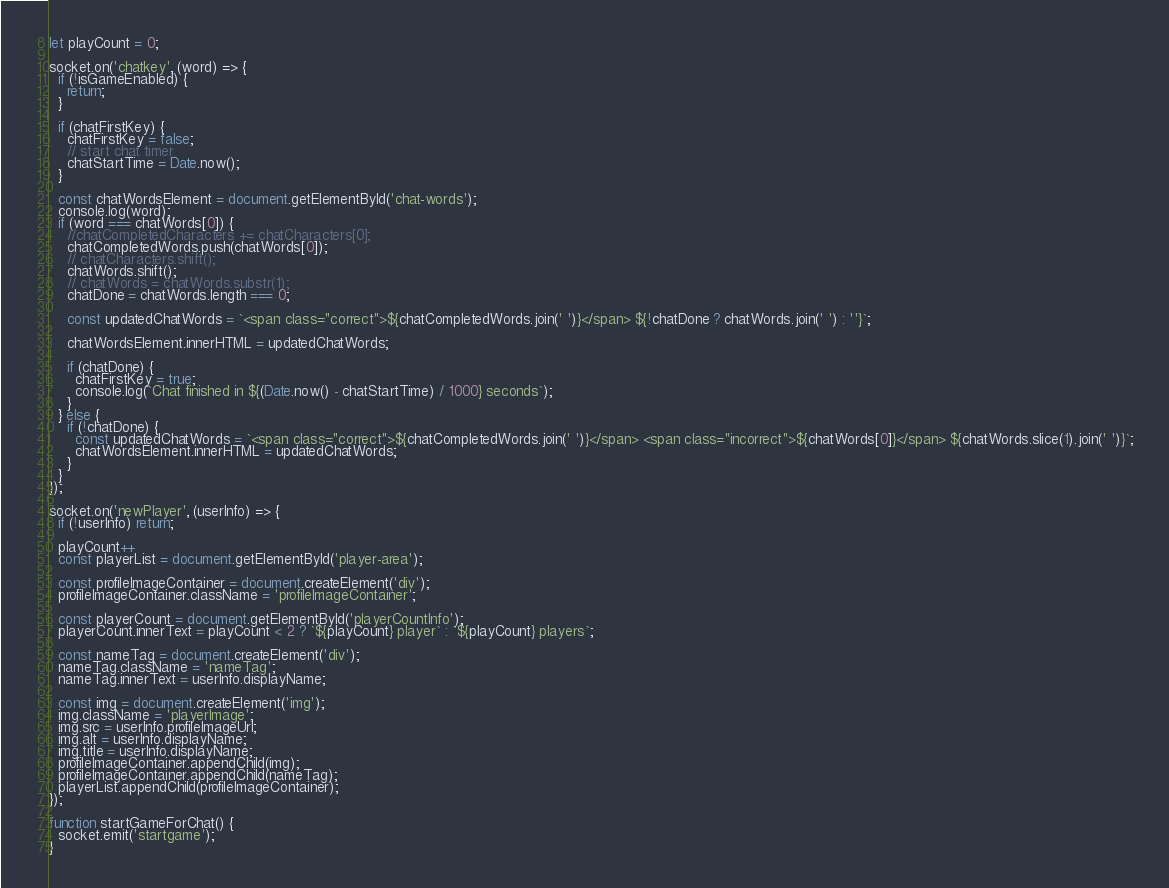<code> <loc_0><loc_0><loc_500><loc_500><_JavaScript_>let playCount = 0;

socket.on('chatkey', (word) => {
  if (!isGameEnabled) {
    return;
  }

  if (chatFirstKey) {
    chatFirstKey = false;
    // start chat timer
    chatStartTime = Date.now();
  }

  const chatWordsElement = document.getElementById('chat-words');
  console.log(word);
  if (word === chatWords[0]) {
    //chatCompletedCharacters += chatCharacters[0];
    chatCompletedWords.push(chatWords[0]);
    // chatCharacters.shift();
    chatWords.shift();
    // chatWords = chatWords.substr(1);
    chatDone = chatWords.length === 0;

    const updatedChatWords = `<span class="correct">${chatCompletedWords.join(' ')}</span> ${!chatDone ? chatWords.join(' ') : ''}`;

    chatWordsElement.innerHTML = updatedChatWords;

    if (chatDone) {
      chatFirstKey = true;
      console.log(`Chat finished in ${(Date.now() - chatStartTime) / 1000} seconds`);
    }
  } else {
    if (!chatDone) {
      const updatedChatWords = `<span class="correct">${chatCompletedWords.join(' ')}</span> <span class="incorrect">${chatWords[0]}</span> ${chatWords.slice(1).join(' ')}`;
      chatWordsElement.innerHTML = updatedChatWords;
    }
  }
});

socket.on('newPlayer', (userInfo) => {
  if (!userInfo) return;

  playCount++
  const playerList = document.getElementById('player-area');

  const profileImageContainer = document.createElement('div');
  profileImageContainer.className = 'profileImageContainer';

  const playerCount = document.getElementById('playerCountInfo');
  playerCount.innerText = playCount < 2 ? `${playCount} player` : `${playCount} players`;

  const nameTag = document.createElement('div');
  nameTag.className = 'nameTag';
  nameTag.innerText = userInfo.displayName;

  const img = document.createElement('img');
  img.className = 'playerImage';
  img.src = userInfo.profileImageUrl;
  img.alt = userInfo.displayName;
  img.title = userInfo.displayName;
  profileImageContainer.appendChild(img);
  profileImageContainer.appendChild(nameTag);
  playerList.appendChild(profileImageContainer);
});

function startGameForChat() {
  socket.emit('startgame');
}
</code> 